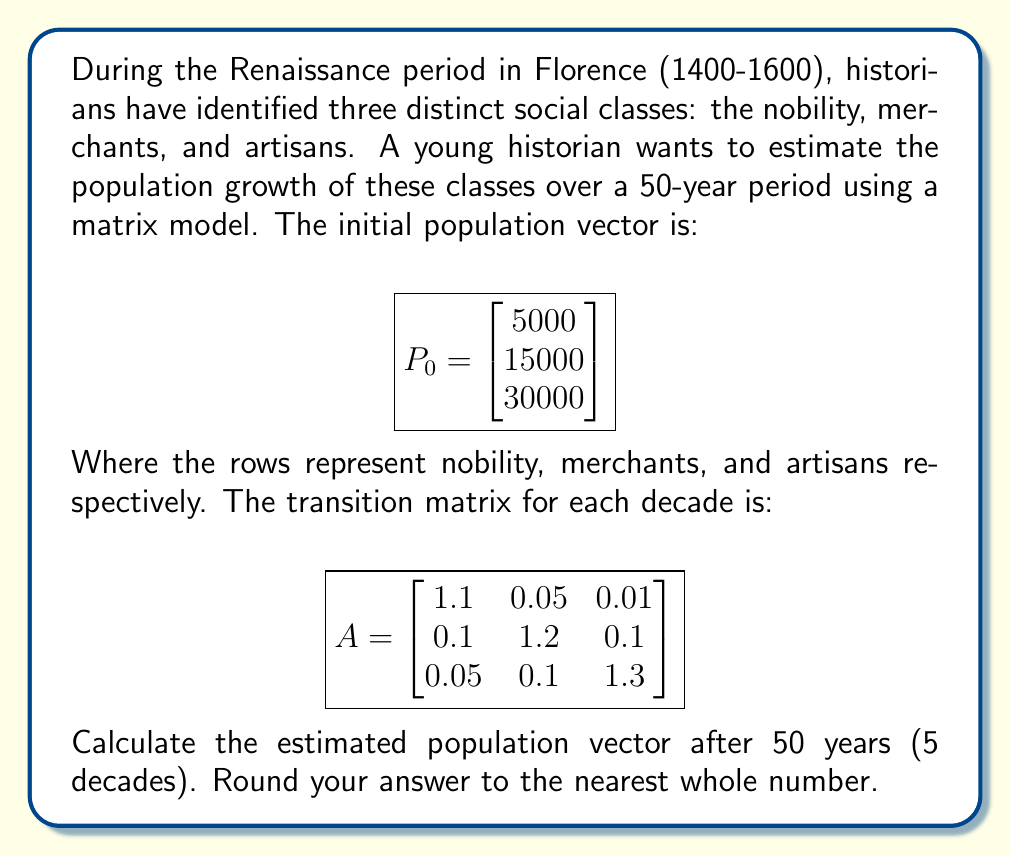Solve this math problem. To solve this problem, we need to use matrix multiplication and exponentiation. Here's a step-by-step explanation:

1) The formula for population growth using a matrix model is:
   $$P_n = A^n P_0$$
   where $n$ is the number of time steps, $A$ is the transition matrix, and $P_0$ is the initial population vector.

2) In this case, $n = 5$ (5 decades), so we need to calculate $A^5$.

3) To calculate $A^5$, we can use the matrix multiplication method five times:
   $$A^5 = A \cdot A \cdot A \cdot A \cdot A$$

4) Using a calculator or computer program, we get:
   $$A^5 \approx \begin{bmatrix} 1.6105 & 0.4726 & 0.3024 \\ 0.9453 & 2.7631 & 1.1901 \\ 0.7229 & 1.4901 & 3.7025 \end{bmatrix}$$

5) Now we can multiply this result by the initial population vector:
   $$P_5 = A^5 P_0 = \begin{bmatrix} 1.6105 & 0.4726 & 0.3024 \\ 0.9453 & 2.7631 & 1.1901 \\ 0.7229 & 1.4901 & 3.7025 \end{bmatrix} \begin{bmatrix} 5000 \\ 15000 \\ 30000 \end{bmatrix}$$

6) Performing this multiplication:
   $$P_5 = \begin{bmatrix} (1.6105 \cdot 5000) + (0.4726 \cdot 15000) + (0.3024 \cdot 30000) \\ (0.9453 \cdot 5000) + (2.7631 \cdot 15000) + (1.1901 \cdot 30000) \\ (0.7229 \cdot 5000) + (1.4901 \cdot 15000) + (3.7025 \cdot 30000) \end{bmatrix}$$

7) Calculating and rounding to the nearest whole number:
   $$P_5 \approx \begin{bmatrix} 24315 \\ 76583 \\ 151830 \end{bmatrix}$$
Answer: $$\begin{bmatrix} 24315 \\ 76583 \\ 151830 \end{bmatrix}$$ 